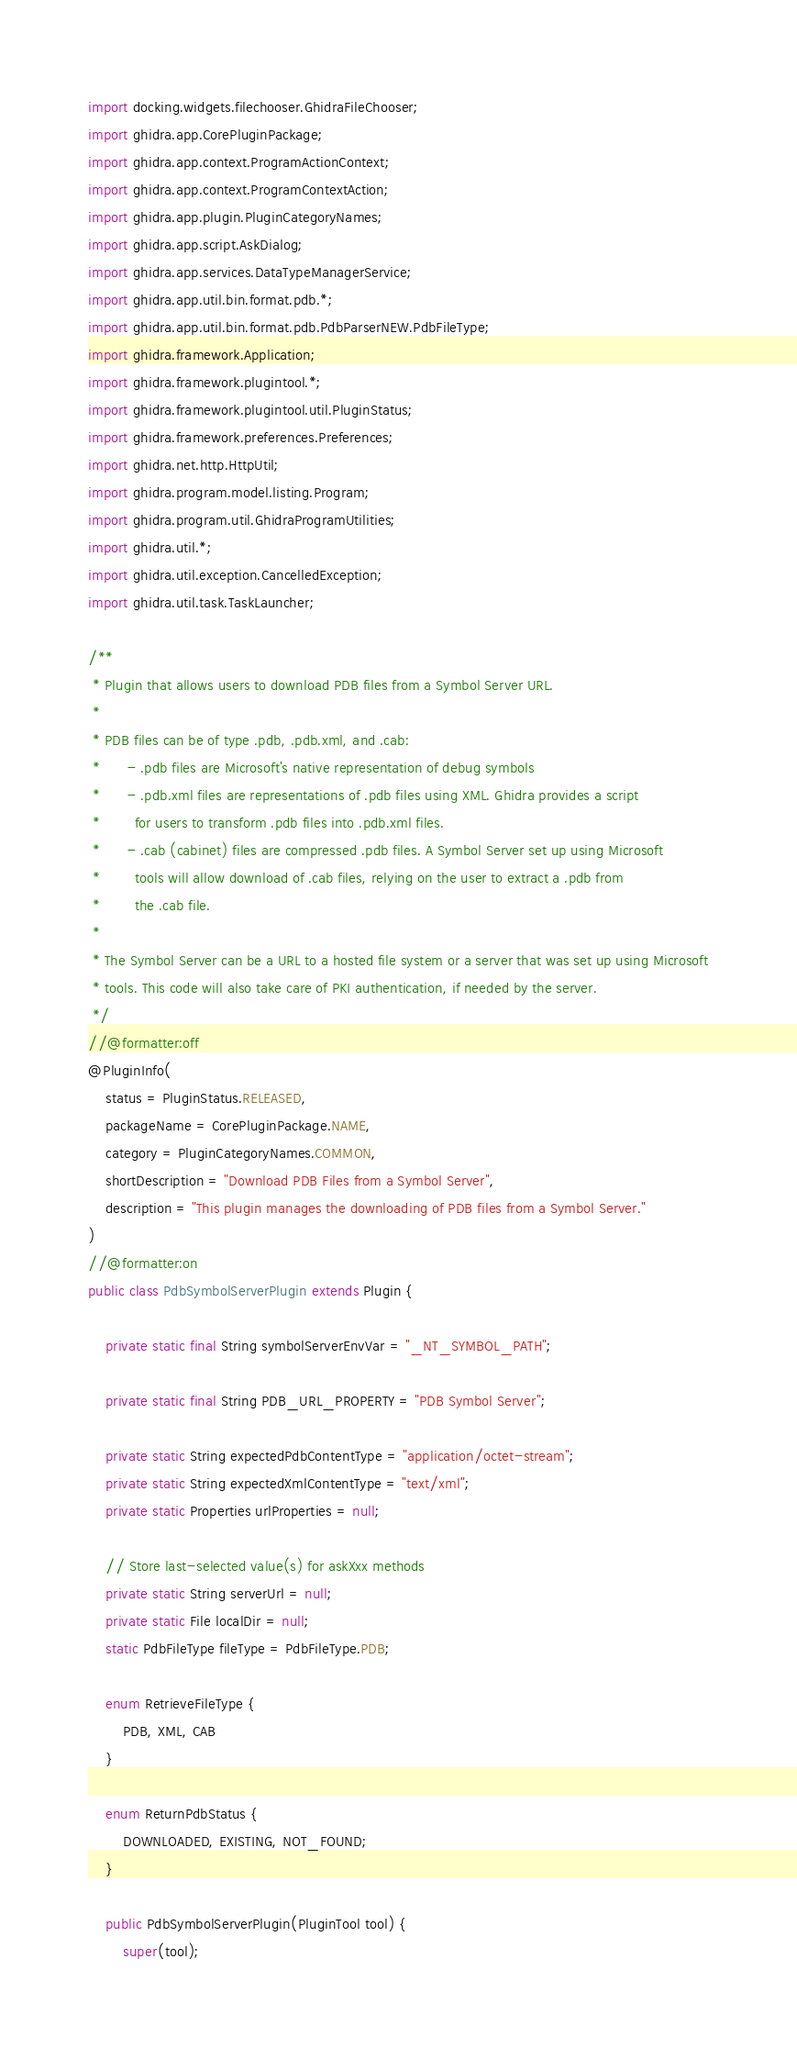<code> <loc_0><loc_0><loc_500><loc_500><_Java_>import docking.widgets.filechooser.GhidraFileChooser;
import ghidra.app.CorePluginPackage;
import ghidra.app.context.ProgramActionContext;
import ghidra.app.context.ProgramContextAction;
import ghidra.app.plugin.PluginCategoryNames;
import ghidra.app.script.AskDialog;
import ghidra.app.services.DataTypeManagerService;
import ghidra.app.util.bin.format.pdb.*;
import ghidra.app.util.bin.format.pdb.PdbParserNEW.PdbFileType;
import ghidra.framework.Application;
import ghidra.framework.plugintool.*;
import ghidra.framework.plugintool.util.PluginStatus;
import ghidra.framework.preferences.Preferences;
import ghidra.net.http.HttpUtil;
import ghidra.program.model.listing.Program;
import ghidra.program.util.GhidraProgramUtilities;
import ghidra.util.*;
import ghidra.util.exception.CancelledException;
import ghidra.util.task.TaskLauncher;

/**
 * Plugin that allows users to download PDB files from a Symbol Server URL.
 *
 * PDB files can be of type .pdb, .pdb.xml, and .cab:
 * 		- .pdb files are Microsoft's native representation of debug symbols
 * 		- .pdb.xml files are representations of .pdb files using XML. Ghidra provides a script
 * 		  for users to transform .pdb files into .pdb.xml files.
 * 		- .cab (cabinet) files are compressed .pdb files. A Symbol Server set up using Microsoft
 * 		  tools will allow download of .cab files, relying on the user to extract a .pdb from
 *        the .cab file.
 *
 * The Symbol Server can be a URL to a hosted file system or a server that was set up using Microsoft
 * tools. This code will also take care of PKI authentication, if needed by the server.
 */
//@formatter:off
@PluginInfo(
	status = PluginStatus.RELEASED,
	packageName = CorePluginPackage.NAME,
	category = PluginCategoryNames.COMMON,
	shortDescription = "Download PDB Files from a Symbol Server",
	description = "This plugin manages the downloading of PDB files from a Symbol Server."
)
//@formatter:on
public class PdbSymbolServerPlugin extends Plugin {

	private static final String symbolServerEnvVar = "_NT_SYMBOL_PATH";

	private static final String PDB_URL_PROPERTY = "PDB Symbol Server";

	private static String expectedPdbContentType = "application/octet-stream";
	private static String expectedXmlContentType = "text/xml";
	private static Properties urlProperties = null;

	// Store last-selected value(s) for askXxx methods
	private static String serverUrl = null;
	private static File localDir = null;
	static PdbFileType fileType = PdbFileType.PDB;

	enum RetrieveFileType {
		PDB, XML, CAB
	}

	enum ReturnPdbStatus {
		DOWNLOADED, EXISTING, NOT_FOUND;
	}

	public PdbSymbolServerPlugin(PluginTool tool) {
		super(tool);</code> 